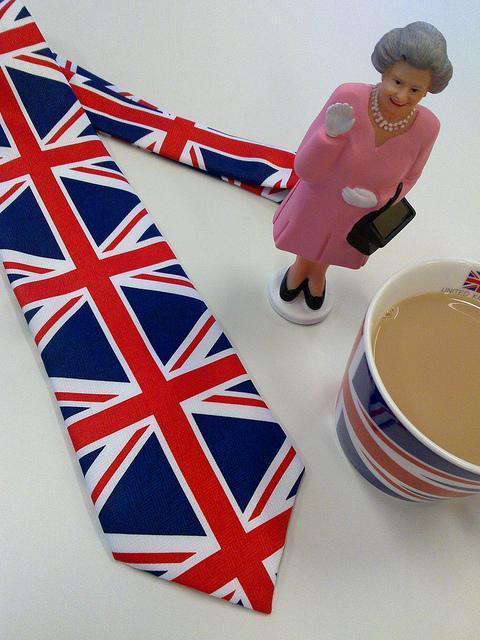How many ties are shown?
Give a very brief answer. 1. How many colors are present?
Give a very brief answer. 7. How many carrots are on the plate?
Give a very brief answer. 0. 